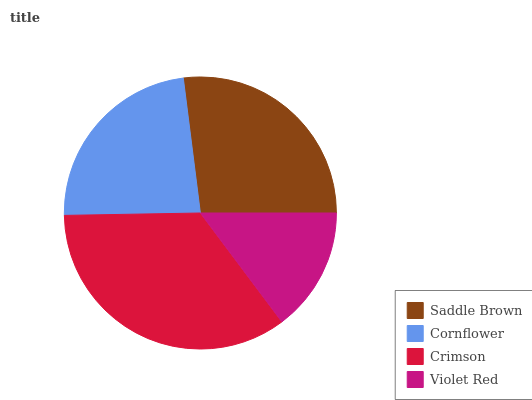Is Violet Red the minimum?
Answer yes or no. Yes. Is Crimson the maximum?
Answer yes or no. Yes. Is Cornflower the minimum?
Answer yes or no. No. Is Cornflower the maximum?
Answer yes or no. No. Is Saddle Brown greater than Cornflower?
Answer yes or no. Yes. Is Cornflower less than Saddle Brown?
Answer yes or no. Yes. Is Cornflower greater than Saddle Brown?
Answer yes or no. No. Is Saddle Brown less than Cornflower?
Answer yes or no. No. Is Saddle Brown the high median?
Answer yes or no. Yes. Is Cornflower the low median?
Answer yes or no. Yes. Is Crimson the high median?
Answer yes or no. No. Is Violet Red the low median?
Answer yes or no. No. 